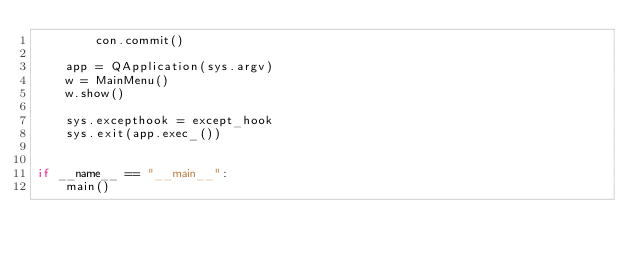<code> <loc_0><loc_0><loc_500><loc_500><_Python_>        con.commit()

    app = QApplication(sys.argv)
    w = MainMenu()
    w.show()

    sys.excepthook = except_hook
    sys.exit(app.exec_())


if __name__ == "__main__":
    main()
</code> 